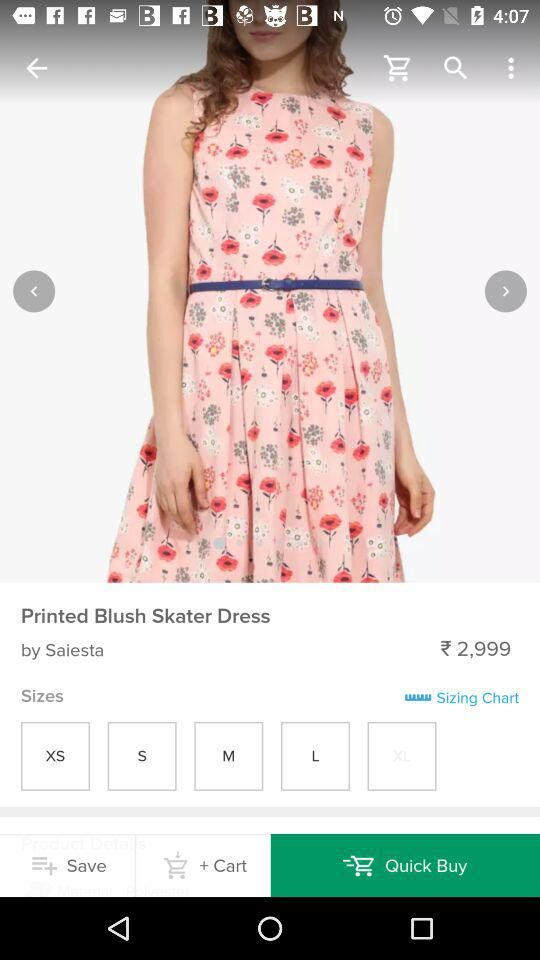What is the dress name? The dress name is "Printed Blush Skater Dress". 